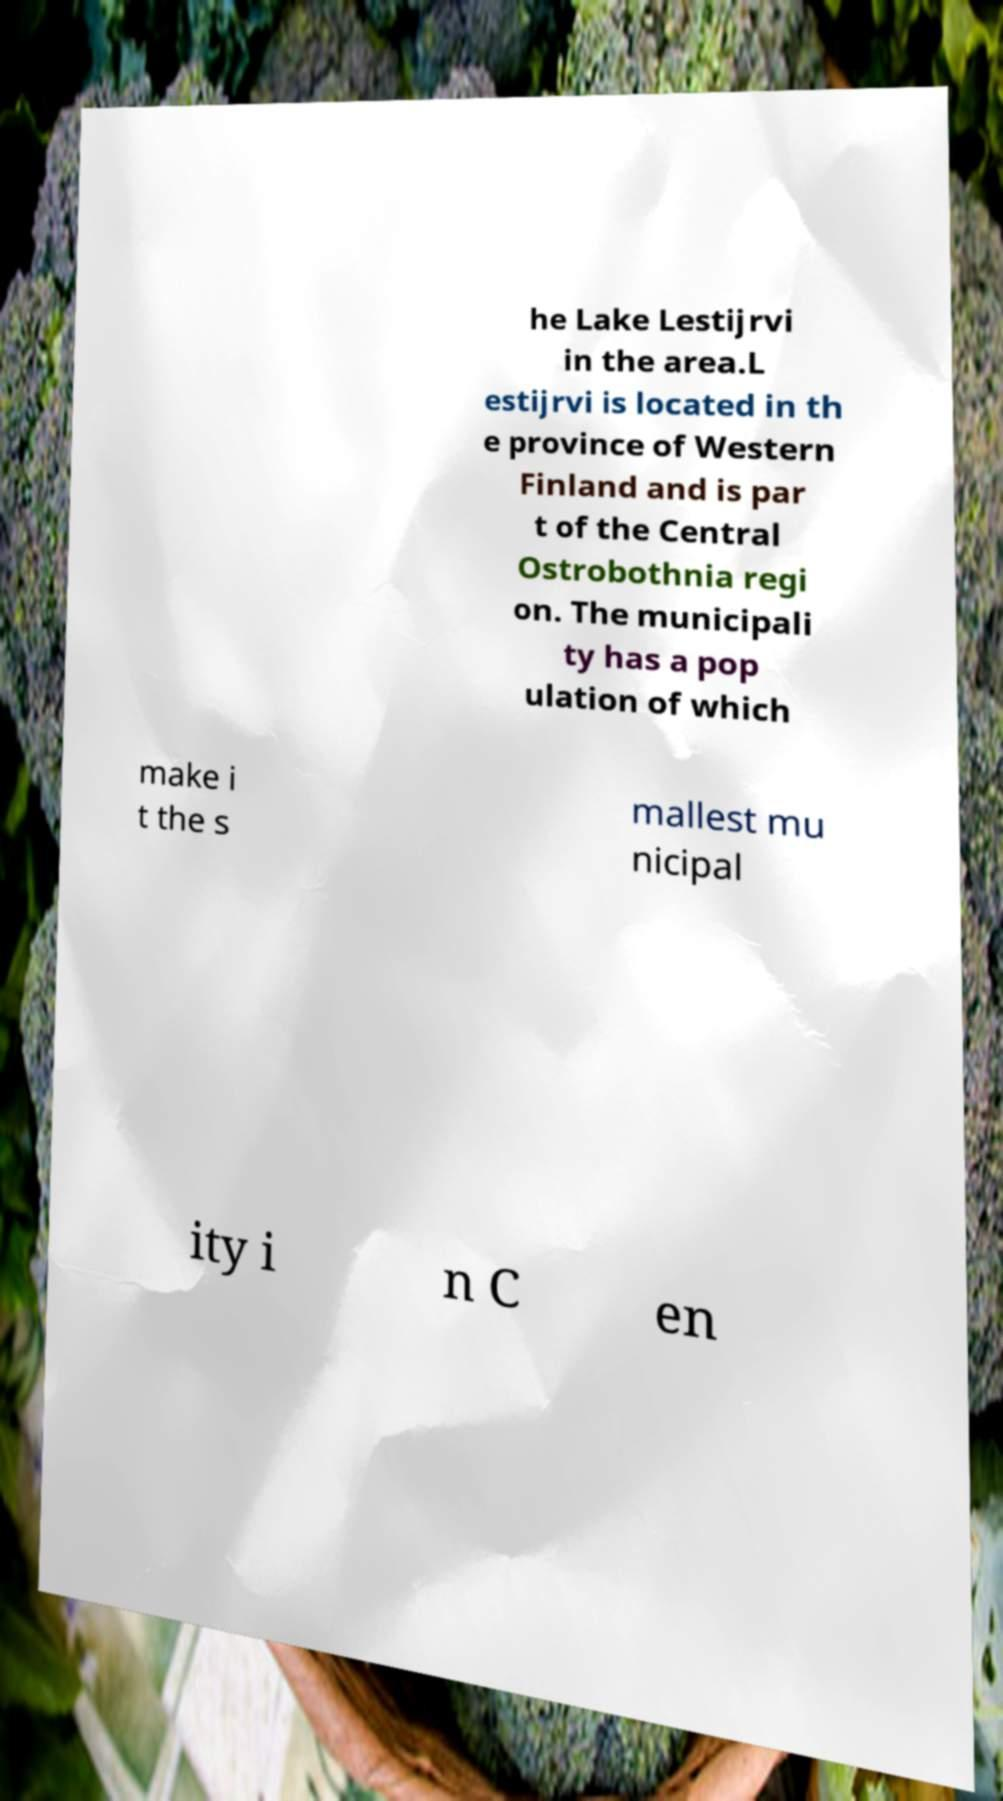What messages or text are displayed in this image? I need them in a readable, typed format. he Lake Lestijrvi in the area.L estijrvi is located in th e province of Western Finland and is par t of the Central Ostrobothnia regi on. The municipali ty has a pop ulation of which make i t the s mallest mu nicipal ity i n C en 